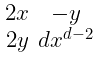<formula> <loc_0><loc_0><loc_500><loc_500>\begin{smallmatrix} 2 x & - y \\ 2 y & d x ^ { d - 2 } \end{smallmatrix}</formula> 